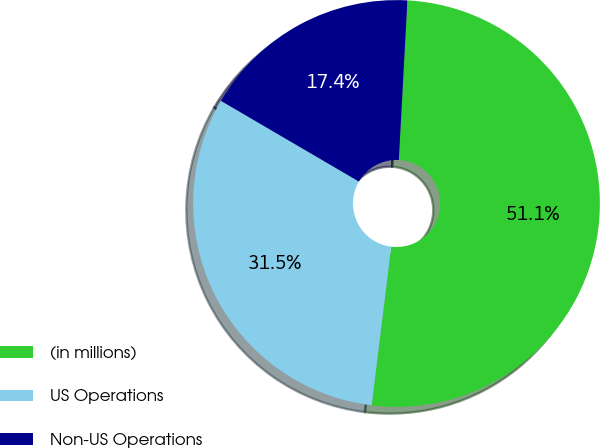<chart> <loc_0><loc_0><loc_500><loc_500><pie_chart><fcel>(in millions)<fcel>US Operations<fcel>Non-US Operations<nl><fcel>51.09%<fcel>31.47%<fcel>17.43%<nl></chart> 